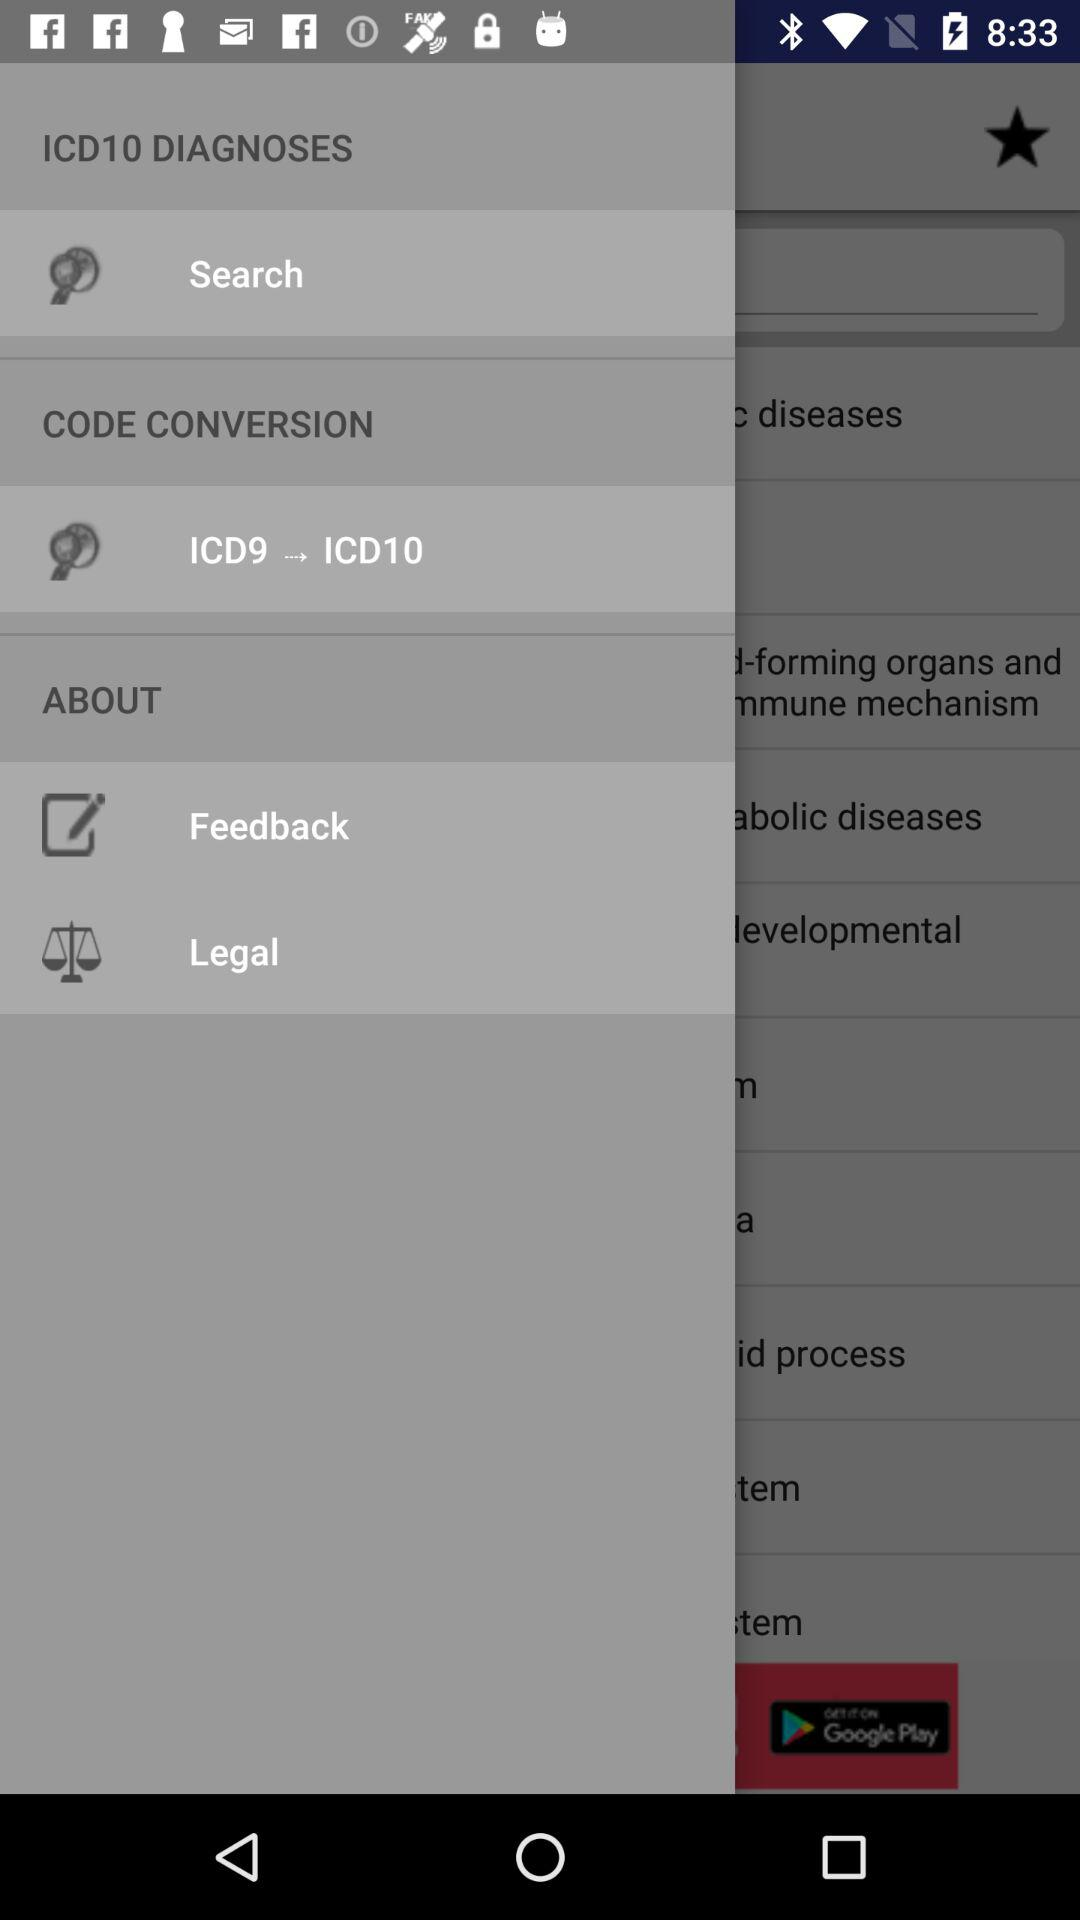What is the converted code? The converted code is "ICD9 → ICD10". 